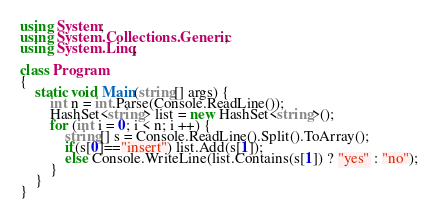Convert code to text. <code><loc_0><loc_0><loc_500><loc_500><_C#_>using System;
using System.Collections.Generic;
using System.Linq;

class Program
{
    static void Main(string[] args) {
        int n = int.Parse(Console.ReadLine());
        HashSet<string> list = new HashSet<string>();
        for (int i = 0; i < n; i ++) {
            string[] s = Console.ReadLine().Split().ToArray();
            if(s[0]=="insert") list.Add(s[1]);
            else Console.WriteLine(list.Contains(s[1]) ? "yes" : "no");
        }
    }
}
</code> 